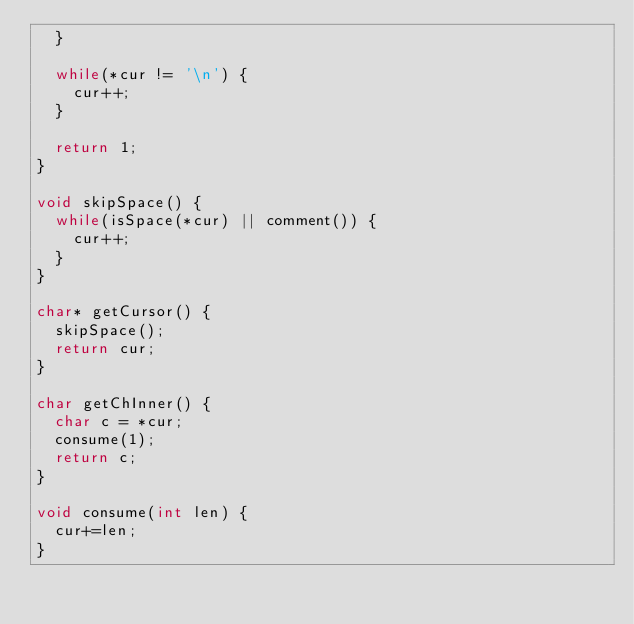<code> <loc_0><loc_0><loc_500><loc_500><_C_>  }

  while(*cur != '\n') {
    cur++;
  }

  return 1;
}

void skipSpace() {
  while(isSpace(*cur) || comment()) {
    cur++;
  }
}

char* getCursor() {
  skipSpace();
  return cur;
}

char getChInner() {
  char c = *cur;
  consume(1);
  return c;
}

void consume(int len) {
  cur+=len;
}
</code> 